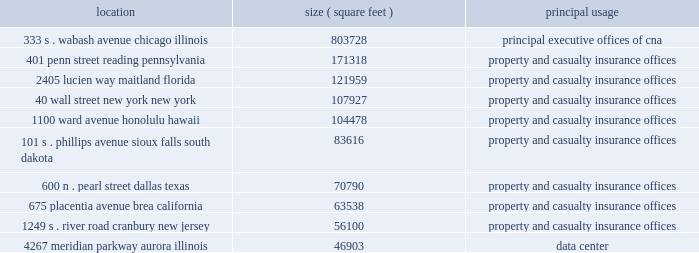Item 1 .
Business cna financial corporation ( continued ) and possible regulatory limitations , impositions and restrictions arising from the emergency economic stabilization act of 2008 .
Properties : the 333 s .
Wabash avenue building , located in chicago , illinois and owned by ccc , a wholly owned subsidiary of cna , serves as the home office for cna and its insurance subsidiaries .
Cna owns or leases office space in various cities throughout the united states and in other countries .
The table sets forth certain information with respect to the principal office buildings owned or leased by cna : location ( square feet ) principal usage 333 s .
Wabash avenue 803728 principal executive offices of cna chicago , illinois 401 penn street 171318 property and casualty insurance offices reading , pennsylvania 2405 lucien way 121959 property and casualty insurance offices maitland , florida 40 wall street 107927 property and casualty insurance offices new york , new york 1100 ward avenue 104478 property and casualty insurance offices honolulu , hawaii 101 s .
Phillips avenue 83616 property and casualty insurance offices sioux falls , south dakota 600 n .
Pearl street 70790 property and casualty insurance offices dallas , texas 675 placentia avenue 63538 property and casualty insurance offices brea , california 1249 s .
River road 56100 property and casualty insurance offices cranbury , new jersey 4267 meridian parkway 46903 data center aurora , illinois cna leases its office space described above except for the chicago , illinois building , the reading , pennsylvania building , and the aurora , illinois building , which are owned .
Diamond offshore drilling , inc .
Diamond offshore drilling , inc .
( 201cdiamond offshore 201d ) , is engaged , through its subsidiaries , in the business of owning and operating drilling rigs that are used in the drilling of offshore oil and gas wells on a contract basis for companies engaged in exploration and production of hydrocarbons .
Diamond offshore owns 47 offshore rigs .
Diamond offshore accounted for 25.9% ( 25.9 % ) , 26.3% ( 26.3 % ) and 18.3% ( 18.3 % ) of our consolidated total revenue for the years ended december 31 , 2009 , 2008 and 2007 .
Diamond offshore owns and operates 32 semisubmersible rigs , consisting of 13 high specification and 19 intermediate rigs .
Semisubmersible rigs consist of an upper working and living deck resting on vertical columns connected to lower hull members .
Such rigs operate in a 201csemi-submerged 201d position , remaining afloat , off bottom , in a position in which the lower hull is approximately 55 feet to 90 feet below the water line and the upper deck protrudes well above the surface .
Semisubmersible rigs are typically anchored in position and remain stable for drilling in the semi-submerged floating position due in part to their wave transparency characteristics at the water line .
Semisubmersible rigs can also be held in position through the use of a computer controlled thruster ( 201cdynamic-positioning 201d ) system to maintain the rig 2019s position over a drillsite .
Five semisubmersible rigs in diamond offshore 2019s fleet have this capability .
Diamond offshore 2019s high specification semisubmersible rigs are generally capable of working in water depths of 4000 feet or greater or in harsh environments and have other advanced features , as compared to intermediate semisubmersible rigs .
As of january 25 , 2010 , seven of the 13 high specification semisubmersible rigs , including the recently acquired ocean courage , were located in the u.s .
Gulf of mexico ( 201cgom 201d ) .
At that date diamond offshore had two high specification semisubmersible rigs operating offshore brazil , while a third was en route to brazil from the gom .
Of .
Item 1 .
Business cna financial corporation ( continued ) and possible regulatory limitations , impositions and restrictions arising from the emergency economic stabilization act of 2008 .
Properties : the 333 s .
Wabash avenue building , located in chicago , illinois and owned by ccc , a wholly owned subsidiary of cna , serves as the home office for cna and its insurance subsidiaries .
Cna owns or leases office space in various cities throughout the united states and in other countries .
The following table sets forth certain information with respect to the principal office buildings owned or leased by cna : location ( square feet ) principal usage 333 s .
Wabash avenue 803728 principal executive offices of cna chicago , illinois 401 penn street 171318 property and casualty insurance offices reading , pennsylvania 2405 lucien way 121959 property and casualty insurance offices maitland , florida 40 wall street 107927 property and casualty insurance offices new york , new york 1100 ward avenue 104478 property and casualty insurance offices honolulu , hawaii 101 s .
Phillips avenue 83616 property and casualty insurance offices sioux falls , south dakota 600 n .
Pearl street 70790 property and casualty insurance offices dallas , texas 675 placentia avenue 63538 property and casualty insurance offices brea , california 1249 s .
River road 56100 property and casualty insurance offices cranbury , new jersey 4267 meridian parkway 46903 data center aurora , illinois cna leases its office space described above except for the chicago , illinois building , the reading , pennsylvania building , and the aurora , illinois building , which are owned .
Diamond offshore drilling , inc .
Diamond offshore drilling , inc .
( 201cdiamond offshore 201d ) , is engaged , through its subsidiaries , in the business of owning and operating drilling rigs that are used in the drilling of offshore oil and gas wells on a contract basis for companies engaged in exploration and production of hydrocarbons .
Diamond offshore owns 47 offshore rigs .
Diamond offshore accounted for 25.9% ( 25.9 % ) , 26.3% ( 26.3 % ) and 18.3% ( 18.3 % ) of our consolidated total revenue for the years ended december 31 , 2009 , 2008 and 2007 .
Diamond offshore owns and operates 32 semisubmersible rigs , consisting of 13 high specification and 19 intermediate rigs .
Semisubmersible rigs consist of an upper working and living deck resting on vertical columns connected to lower hull members .
Such rigs operate in a 201csemi-submerged 201d position , remaining afloat , off bottom , in a position in which the lower hull is approximately 55 feet to 90 feet below the water line and the upper deck protrudes well above the surface .
Semisubmersible rigs are typically anchored in position and remain stable for drilling in the semi-submerged floating position due in part to their wave transparency characteristics at the water line .
Semisubmersible rigs can also be held in position through the use of a computer controlled thruster ( 201cdynamic-positioning 201d ) system to maintain the rig 2019s position over a drillsite .
Five semisubmersible rigs in diamond offshore 2019s fleet have this capability .
Diamond offshore 2019s high specification semisubmersible rigs are generally capable of working in water depths of 4000 feet or greater or in harsh environments and have other advanced features , as compared to intermediate semisubmersible rigs .
As of january 25 , 2010 , seven of the 13 high specification semisubmersible rigs , including the recently acquired ocean courage , were located in the u.s .
Gulf of mexico ( 201cgom 201d ) .
At that date diamond offshore had two high specification semisubmersible rigs operating offshore brazil , while a third was en route to brazil from the gom .
Of .
What was cnas total square footage in illinois? 
Computations: (46903 + 803728)
Answer: 850631.0. Item 1 .
Business cna financial corporation ( continued ) and possible regulatory limitations , impositions and restrictions arising from the emergency economic stabilization act of 2008 .
Properties : the 333 s .
Wabash avenue building , located in chicago , illinois and owned by ccc , a wholly owned subsidiary of cna , serves as the home office for cna and its insurance subsidiaries .
Cna owns or leases office space in various cities throughout the united states and in other countries .
The table sets forth certain information with respect to the principal office buildings owned or leased by cna : location ( square feet ) principal usage 333 s .
Wabash avenue 803728 principal executive offices of cna chicago , illinois 401 penn street 171318 property and casualty insurance offices reading , pennsylvania 2405 lucien way 121959 property and casualty insurance offices maitland , florida 40 wall street 107927 property and casualty insurance offices new york , new york 1100 ward avenue 104478 property and casualty insurance offices honolulu , hawaii 101 s .
Phillips avenue 83616 property and casualty insurance offices sioux falls , south dakota 600 n .
Pearl street 70790 property and casualty insurance offices dallas , texas 675 placentia avenue 63538 property and casualty insurance offices brea , california 1249 s .
River road 56100 property and casualty insurance offices cranbury , new jersey 4267 meridian parkway 46903 data center aurora , illinois cna leases its office space described above except for the chicago , illinois building , the reading , pennsylvania building , and the aurora , illinois building , which are owned .
Diamond offshore drilling , inc .
Diamond offshore drilling , inc .
( 201cdiamond offshore 201d ) , is engaged , through its subsidiaries , in the business of owning and operating drilling rigs that are used in the drilling of offshore oil and gas wells on a contract basis for companies engaged in exploration and production of hydrocarbons .
Diamond offshore owns 47 offshore rigs .
Diamond offshore accounted for 25.9% ( 25.9 % ) , 26.3% ( 26.3 % ) and 18.3% ( 18.3 % ) of our consolidated total revenue for the years ended december 31 , 2009 , 2008 and 2007 .
Diamond offshore owns and operates 32 semisubmersible rigs , consisting of 13 high specification and 19 intermediate rigs .
Semisubmersible rigs consist of an upper working and living deck resting on vertical columns connected to lower hull members .
Such rigs operate in a 201csemi-submerged 201d position , remaining afloat , off bottom , in a position in which the lower hull is approximately 55 feet to 90 feet below the water line and the upper deck protrudes well above the surface .
Semisubmersible rigs are typically anchored in position and remain stable for drilling in the semi-submerged floating position due in part to their wave transparency characteristics at the water line .
Semisubmersible rigs can also be held in position through the use of a computer controlled thruster ( 201cdynamic-positioning 201d ) system to maintain the rig 2019s position over a drillsite .
Five semisubmersible rigs in diamond offshore 2019s fleet have this capability .
Diamond offshore 2019s high specification semisubmersible rigs are generally capable of working in water depths of 4000 feet or greater or in harsh environments and have other advanced features , as compared to intermediate semisubmersible rigs .
As of january 25 , 2010 , seven of the 13 high specification semisubmersible rigs , including the recently acquired ocean courage , were located in the u.s .
Gulf of mexico ( 201cgom 201d ) .
At that date diamond offshore had two high specification semisubmersible rigs operating offshore brazil , while a third was en route to brazil from the gom .
Of .
Item 1 .
Business cna financial corporation ( continued ) and possible regulatory limitations , impositions and restrictions arising from the emergency economic stabilization act of 2008 .
Properties : the 333 s .
Wabash avenue building , located in chicago , illinois and owned by ccc , a wholly owned subsidiary of cna , serves as the home office for cna and its insurance subsidiaries .
Cna owns or leases office space in various cities throughout the united states and in other countries .
The following table sets forth certain information with respect to the principal office buildings owned or leased by cna : location ( square feet ) principal usage 333 s .
Wabash avenue 803728 principal executive offices of cna chicago , illinois 401 penn street 171318 property and casualty insurance offices reading , pennsylvania 2405 lucien way 121959 property and casualty insurance offices maitland , florida 40 wall street 107927 property and casualty insurance offices new york , new york 1100 ward avenue 104478 property and casualty insurance offices honolulu , hawaii 101 s .
Phillips avenue 83616 property and casualty insurance offices sioux falls , south dakota 600 n .
Pearl street 70790 property and casualty insurance offices dallas , texas 675 placentia avenue 63538 property and casualty insurance offices brea , california 1249 s .
River road 56100 property and casualty insurance offices cranbury , new jersey 4267 meridian parkway 46903 data center aurora , illinois cna leases its office space described above except for the chicago , illinois building , the reading , pennsylvania building , and the aurora , illinois building , which are owned .
Diamond offshore drilling , inc .
Diamond offshore drilling , inc .
( 201cdiamond offshore 201d ) , is engaged , through its subsidiaries , in the business of owning and operating drilling rigs that are used in the drilling of offshore oil and gas wells on a contract basis for companies engaged in exploration and production of hydrocarbons .
Diamond offshore owns 47 offshore rigs .
Diamond offshore accounted for 25.9% ( 25.9 % ) , 26.3% ( 26.3 % ) and 18.3% ( 18.3 % ) of our consolidated total revenue for the years ended december 31 , 2009 , 2008 and 2007 .
Diamond offshore owns and operates 32 semisubmersible rigs , consisting of 13 high specification and 19 intermediate rigs .
Semisubmersible rigs consist of an upper working and living deck resting on vertical columns connected to lower hull members .
Such rigs operate in a 201csemi-submerged 201d position , remaining afloat , off bottom , in a position in which the lower hull is approximately 55 feet to 90 feet below the water line and the upper deck protrudes well above the surface .
Semisubmersible rigs are typically anchored in position and remain stable for drilling in the semi-submerged floating position due in part to their wave transparency characteristics at the water line .
Semisubmersible rigs can also be held in position through the use of a computer controlled thruster ( 201cdynamic-positioning 201d ) system to maintain the rig 2019s position over a drillsite .
Five semisubmersible rigs in diamond offshore 2019s fleet have this capability .
Diamond offshore 2019s high specification semisubmersible rigs are generally capable of working in water depths of 4000 feet or greater or in harsh environments and have other advanced features , as compared to intermediate semisubmersible rigs .
As of january 25 , 2010 , seven of the 13 high specification semisubmersible rigs , including the recently acquired ocean courage , were located in the u.s .
Gulf of mexico ( 201cgom 201d ) .
At that date diamond offshore had two high specification semisubmersible rigs operating offshore brazil , while a third was en route to brazil from the gom .
Of .
What is diamond offshore's total rig count? 
Computations: (47 + 32)
Answer: 79.0. 